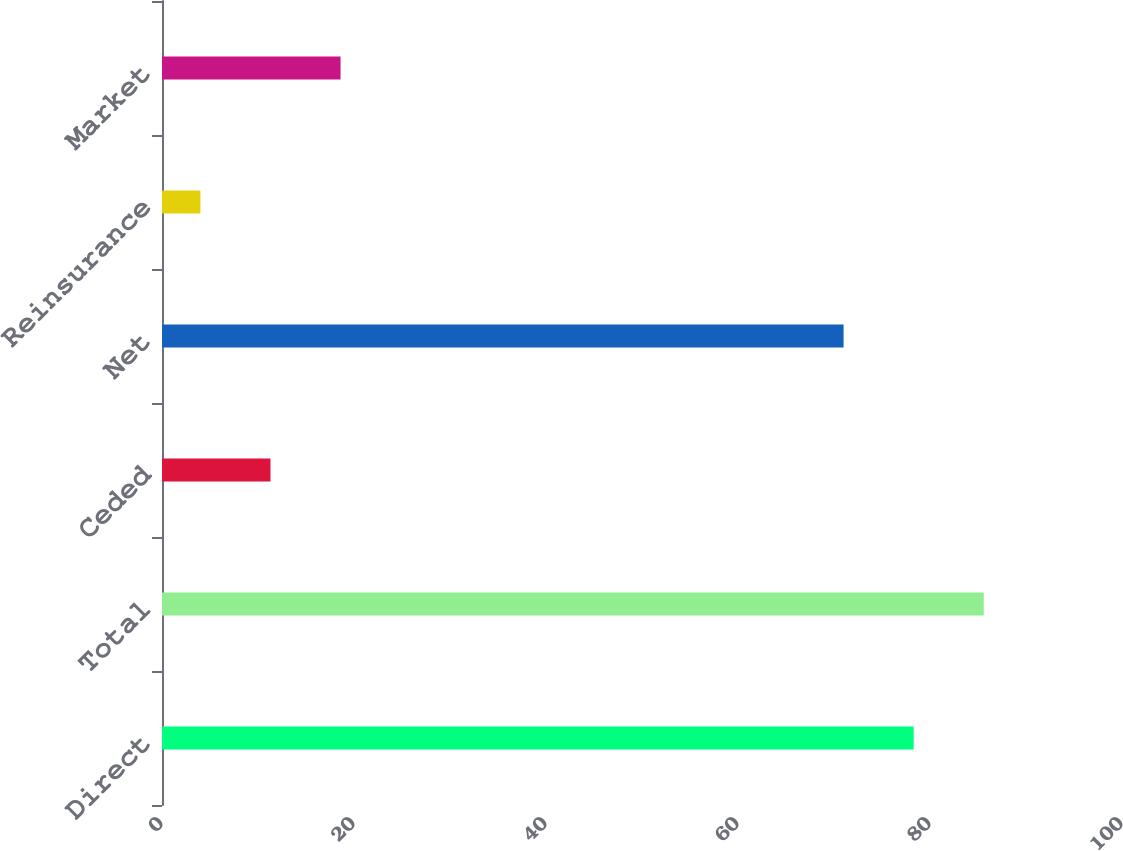Convert chart to OTSL. <chart><loc_0><loc_0><loc_500><loc_500><bar_chart><fcel>Direct<fcel>Total<fcel>Ceded<fcel>Net<fcel>Reinsurance<fcel>Market<nl><fcel>78.3<fcel>85.6<fcel>11.3<fcel>71<fcel>4<fcel>18.6<nl></chart> 